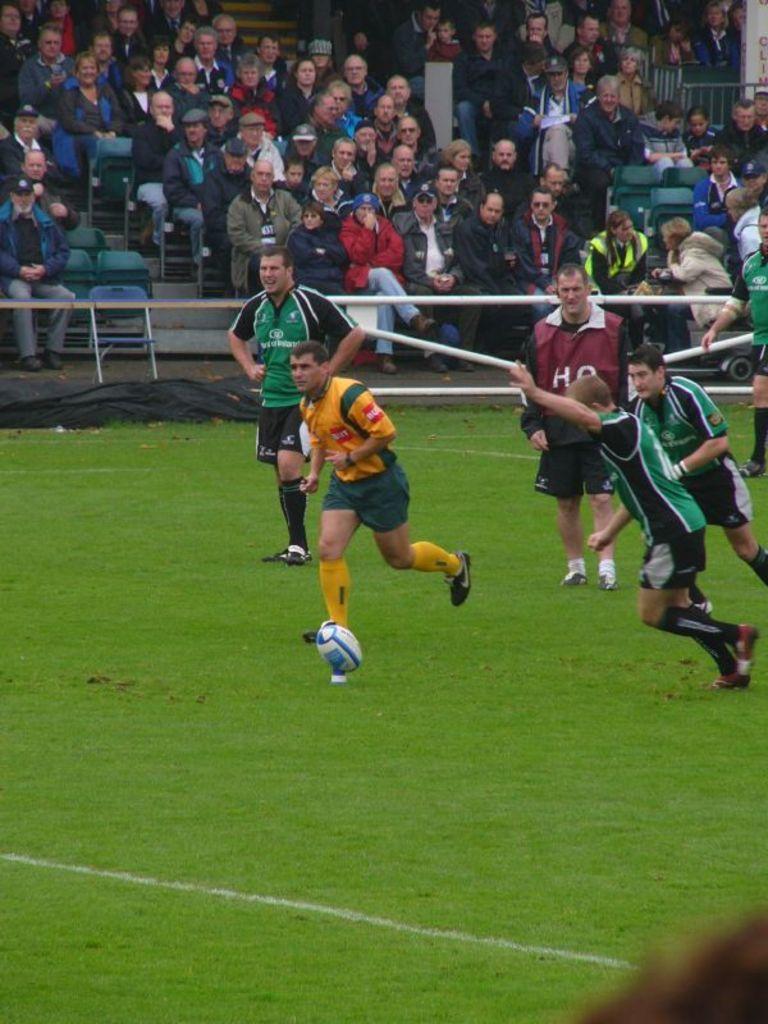Please provide a concise description of this image. In this image I can see grass ground on it I can see few people are running. I can also see a white color ball in the front of them. In the background I can see railings and I can also see number of people are sitting on chairs. On the bottom side of this image I can see a white line on the ground. 